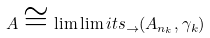<formula> <loc_0><loc_0><loc_500><loc_500>A \cong \lim \lim i t s _ { \rightarrow } ( A _ { n _ { k } } , \gamma _ { k } )</formula> 